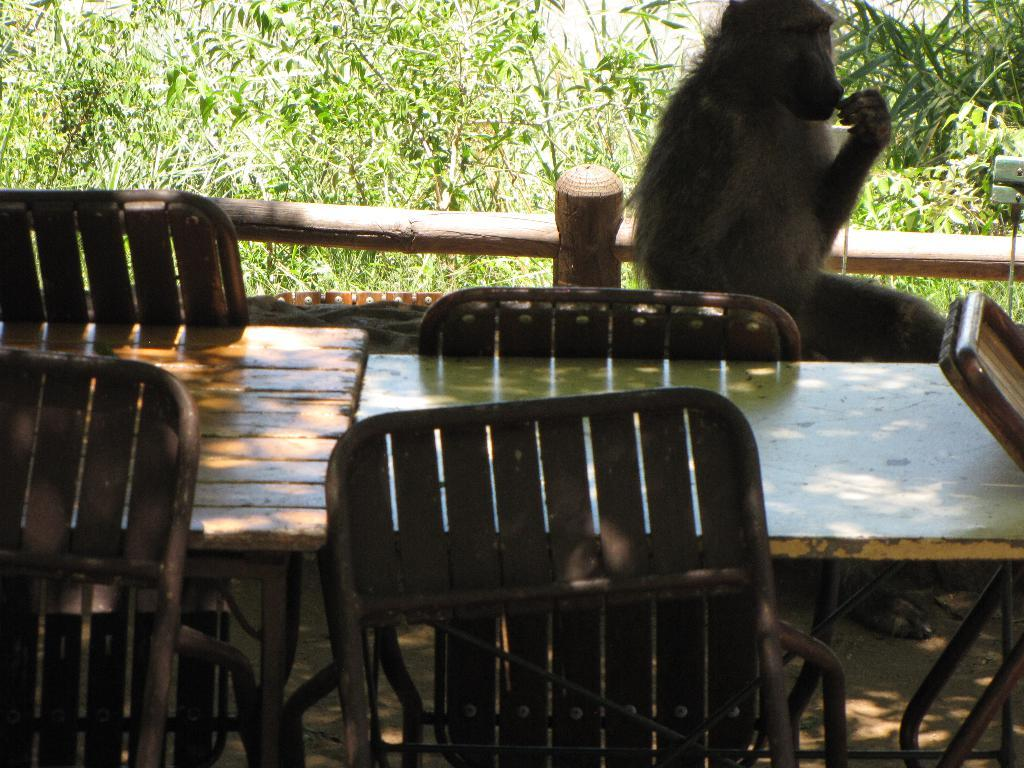Where was the image taken? The image was clicked outside the city. What furniture is visible in the image? There is a table with chairs in the front of the image. What object is placed beside the table? There is money sitting beside the table. What can be seen in the background of the image? There are trees in the background of the image. What type of cork can be seen in the image? There is no cork present in the image. How many eyes are visible on the people in the image? There are no people visible in the image, so it is not possible to determine the number of eyes. 